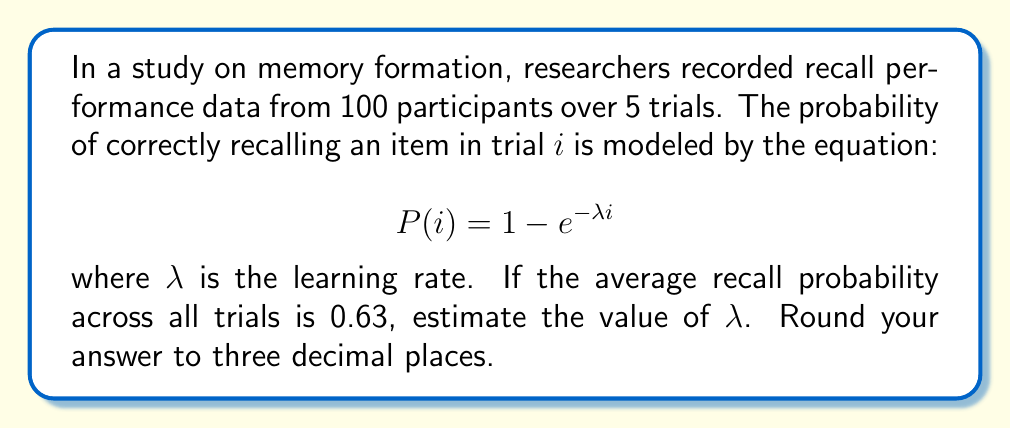Show me your answer to this math problem. To solve this problem, we'll follow these steps:

1) First, we need to find the average of $P(i)$ across all 5 trials:

   $$\frac{1}{5}\sum_{i=1}^{5} P(i) = 0.63$$

2) Substituting the given equation for $P(i)$:

   $$\frac{1}{5}\sum_{i=1}^{5} (1 - e^{-\lambda i}) = 0.63$$

3) Expanding the sum:

   $$\frac{1}{5}[(1 - e^{-\lambda}) + (1 - e^{-2\lambda}) + (1 - e^{-3\lambda}) + (1 - e^{-4\lambda}) + (1 - e^{-5\lambda})] = 0.63$$

4) Simplifying:

   $$1 - \frac{1}{5}(e^{-\lambda} + e^{-2\lambda} + e^{-3\lambda} + e^{-4\lambda} + e^{-5\lambda}) = 0.63$$

5) Rearranging:

   $$\frac{1}{5}(e^{-\lambda} + e^{-2\lambda} + e^{-3\lambda} + e^{-4\lambda} + e^{-5\lambda}) = 0.37$$

6) Let $x = e^{-\lambda}$. Then our equation becomes:

   $$\frac{1}{5}(x + x^2 + x^3 + x^4 + x^5) = 0.37$$

7) This is a complex equation that doesn't have a simple algebraic solution. We need to use numerical methods to solve it. Using a computer algebra system or numerical solver, we find that $x \approx 0.6065$.

8) Since $x = e^{-\lambda}$, we can solve for $\lambda$:

   $$\lambda = -\ln(x) = -\ln(0.6065) \approx 0.500$$

9) Rounding to three decimal places, we get $\lambda \approx 0.500$.
Answer: $\lambda \approx 0.500$ 